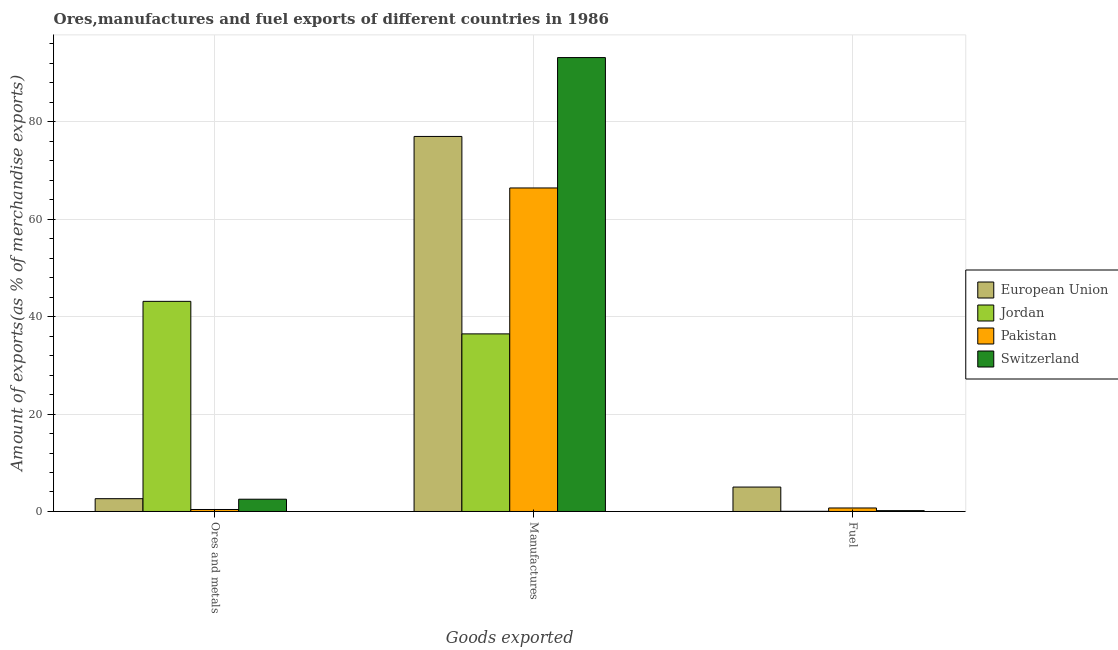How many groups of bars are there?
Give a very brief answer. 3. Are the number of bars on each tick of the X-axis equal?
Offer a very short reply. Yes. What is the label of the 3rd group of bars from the left?
Provide a short and direct response. Fuel. What is the percentage of fuel exports in Jordan?
Make the answer very short. 0.04. Across all countries, what is the maximum percentage of ores and metals exports?
Offer a terse response. 43.12. Across all countries, what is the minimum percentage of manufactures exports?
Ensure brevity in your answer.  36.45. In which country was the percentage of manufactures exports maximum?
Your answer should be compact. Switzerland. What is the total percentage of manufactures exports in the graph?
Provide a short and direct response. 272.94. What is the difference between the percentage of ores and metals exports in Pakistan and that in Jordan?
Your answer should be very brief. -42.71. What is the difference between the percentage of ores and metals exports in European Union and the percentage of manufactures exports in Switzerland?
Provide a succinct answer. -90.52. What is the average percentage of fuel exports per country?
Offer a terse response. 1.49. What is the difference between the percentage of manufactures exports and percentage of fuel exports in European Union?
Give a very brief answer. 71.95. What is the ratio of the percentage of fuel exports in Switzerland to that in Jordan?
Your answer should be very brief. 4.52. Is the difference between the percentage of fuel exports in Jordan and Switzerland greater than the difference between the percentage of manufactures exports in Jordan and Switzerland?
Keep it short and to the point. Yes. What is the difference between the highest and the second highest percentage of manufactures exports?
Your answer should be very brief. 16.19. What is the difference between the highest and the lowest percentage of ores and metals exports?
Offer a terse response. 42.71. In how many countries, is the percentage of ores and metals exports greater than the average percentage of ores and metals exports taken over all countries?
Keep it short and to the point. 1. Is the sum of the percentage of manufactures exports in European Union and Switzerland greater than the maximum percentage of fuel exports across all countries?
Ensure brevity in your answer.  Yes. What does the 4th bar from the left in Ores and metals represents?
Make the answer very short. Switzerland. What does the 3rd bar from the right in Manufactures represents?
Your answer should be very brief. Jordan. How many countries are there in the graph?
Make the answer very short. 4. Does the graph contain grids?
Give a very brief answer. Yes. Where does the legend appear in the graph?
Offer a terse response. Center right. How many legend labels are there?
Your answer should be very brief. 4. How are the legend labels stacked?
Give a very brief answer. Vertical. What is the title of the graph?
Your answer should be compact. Ores,manufactures and fuel exports of different countries in 1986. Does "Luxembourg" appear as one of the legend labels in the graph?
Your answer should be compact. No. What is the label or title of the X-axis?
Offer a very short reply. Goods exported. What is the label or title of the Y-axis?
Your response must be concise. Amount of exports(as % of merchandise exports). What is the Amount of exports(as % of merchandise exports) in European Union in Ores and metals?
Make the answer very short. 2.63. What is the Amount of exports(as % of merchandise exports) of Jordan in Ores and metals?
Ensure brevity in your answer.  43.12. What is the Amount of exports(as % of merchandise exports) of Pakistan in Ores and metals?
Your answer should be very brief. 0.41. What is the Amount of exports(as % of merchandise exports) in Switzerland in Ores and metals?
Offer a terse response. 2.52. What is the Amount of exports(as % of merchandise exports) of European Union in Manufactures?
Keep it short and to the point. 76.96. What is the Amount of exports(as % of merchandise exports) of Jordan in Manufactures?
Offer a very short reply. 36.45. What is the Amount of exports(as % of merchandise exports) in Pakistan in Manufactures?
Your answer should be compact. 66.39. What is the Amount of exports(as % of merchandise exports) of Switzerland in Manufactures?
Provide a short and direct response. 93.15. What is the Amount of exports(as % of merchandise exports) in European Union in Fuel?
Keep it short and to the point. 5.01. What is the Amount of exports(as % of merchandise exports) of Jordan in Fuel?
Make the answer very short. 0.04. What is the Amount of exports(as % of merchandise exports) of Pakistan in Fuel?
Your answer should be very brief. 0.72. What is the Amount of exports(as % of merchandise exports) in Switzerland in Fuel?
Offer a terse response. 0.17. Across all Goods exported, what is the maximum Amount of exports(as % of merchandise exports) in European Union?
Your response must be concise. 76.96. Across all Goods exported, what is the maximum Amount of exports(as % of merchandise exports) of Jordan?
Offer a terse response. 43.12. Across all Goods exported, what is the maximum Amount of exports(as % of merchandise exports) of Pakistan?
Offer a very short reply. 66.39. Across all Goods exported, what is the maximum Amount of exports(as % of merchandise exports) in Switzerland?
Provide a succinct answer. 93.15. Across all Goods exported, what is the minimum Amount of exports(as % of merchandise exports) of European Union?
Provide a short and direct response. 2.63. Across all Goods exported, what is the minimum Amount of exports(as % of merchandise exports) in Jordan?
Your answer should be compact. 0.04. Across all Goods exported, what is the minimum Amount of exports(as % of merchandise exports) in Pakistan?
Your answer should be very brief. 0.41. Across all Goods exported, what is the minimum Amount of exports(as % of merchandise exports) in Switzerland?
Your response must be concise. 0.17. What is the total Amount of exports(as % of merchandise exports) of European Union in the graph?
Give a very brief answer. 84.6. What is the total Amount of exports(as % of merchandise exports) in Jordan in the graph?
Provide a succinct answer. 79.6. What is the total Amount of exports(as % of merchandise exports) of Pakistan in the graph?
Your answer should be compact. 67.52. What is the total Amount of exports(as % of merchandise exports) in Switzerland in the graph?
Offer a terse response. 95.84. What is the difference between the Amount of exports(as % of merchandise exports) of European Union in Ores and metals and that in Manufactures?
Ensure brevity in your answer.  -74.33. What is the difference between the Amount of exports(as % of merchandise exports) of Jordan in Ores and metals and that in Manufactures?
Give a very brief answer. 6.67. What is the difference between the Amount of exports(as % of merchandise exports) of Pakistan in Ores and metals and that in Manufactures?
Offer a very short reply. -65.98. What is the difference between the Amount of exports(as % of merchandise exports) in Switzerland in Ores and metals and that in Manufactures?
Provide a short and direct response. -90.63. What is the difference between the Amount of exports(as % of merchandise exports) of European Union in Ores and metals and that in Fuel?
Provide a short and direct response. -2.39. What is the difference between the Amount of exports(as % of merchandise exports) of Jordan in Ores and metals and that in Fuel?
Provide a succinct answer. 43.08. What is the difference between the Amount of exports(as % of merchandise exports) of Pakistan in Ores and metals and that in Fuel?
Provide a succinct answer. -0.31. What is the difference between the Amount of exports(as % of merchandise exports) in Switzerland in Ores and metals and that in Fuel?
Keep it short and to the point. 2.35. What is the difference between the Amount of exports(as % of merchandise exports) in European Union in Manufactures and that in Fuel?
Your answer should be very brief. 71.95. What is the difference between the Amount of exports(as % of merchandise exports) of Jordan in Manufactures and that in Fuel?
Give a very brief answer. 36.41. What is the difference between the Amount of exports(as % of merchandise exports) in Pakistan in Manufactures and that in Fuel?
Your answer should be very brief. 65.67. What is the difference between the Amount of exports(as % of merchandise exports) of Switzerland in Manufactures and that in Fuel?
Your answer should be very brief. 92.98. What is the difference between the Amount of exports(as % of merchandise exports) in European Union in Ores and metals and the Amount of exports(as % of merchandise exports) in Jordan in Manufactures?
Offer a terse response. -33.82. What is the difference between the Amount of exports(as % of merchandise exports) of European Union in Ores and metals and the Amount of exports(as % of merchandise exports) of Pakistan in Manufactures?
Offer a terse response. -63.76. What is the difference between the Amount of exports(as % of merchandise exports) of European Union in Ores and metals and the Amount of exports(as % of merchandise exports) of Switzerland in Manufactures?
Offer a terse response. -90.52. What is the difference between the Amount of exports(as % of merchandise exports) in Jordan in Ores and metals and the Amount of exports(as % of merchandise exports) in Pakistan in Manufactures?
Provide a short and direct response. -23.27. What is the difference between the Amount of exports(as % of merchandise exports) in Jordan in Ores and metals and the Amount of exports(as % of merchandise exports) in Switzerland in Manufactures?
Make the answer very short. -50.03. What is the difference between the Amount of exports(as % of merchandise exports) in Pakistan in Ores and metals and the Amount of exports(as % of merchandise exports) in Switzerland in Manufactures?
Provide a short and direct response. -92.74. What is the difference between the Amount of exports(as % of merchandise exports) of European Union in Ores and metals and the Amount of exports(as % of merchandise exports) of Jordan in Fuel?
Provide a succinct answer. 2.59. What is the difference between the Amount of exports(as % of merchandise exports) of European Union in Ores and metals and the Amount of exports(as % of merchandise exports) of Pakistan in Fuel?
Keep it short and to the point. 1.91. What is the difference between the Amount of exports(as % of merchandise exports) in European Union in Ores and metals and the Amount of exports(as % of merchandise exports) in Switzerland in Fuel?
Offer a terse response. 2.46. What is the difference between the Amount of exports(as % of merchandise exports) of Jordan in Ores and metals and the Amount of exports(as % of merchandise exports) of Pakistan in Fuel?
Your response must be concise. 42.4. What is the difference between the Amount of exports(as % of merchandise exports) in Jordan in Ores and metals and the Amount of exports(as % of merchandise exports) in Switzerland in Fuel?
Ensure brevity in your answer.  42.95. What is the difference between the Amount of exports(as % of merchandise exports) of Pakistan in Ores and metals and the Amount of exports(as % of merchandise exports) of Switzerland in Fuel?
Your answer should be very brief. 0.24. What is the difference between the Amount of exports(as % of merchandise exports) in European Union in Manufactures and the Amount of exports(as % of merchandise exports) in Jordan in Fuel?
Provide a succinct answer. 76.92. What is the difference between the Amount of exports(as % of merchandise exports) in European Union in Manufactures and the Amount of exports(as % of merchandise exports) in Pakistan in Fuel?
Offer a terse response. 76.24. What is the difference between the Amount of exports(as % of merchandise exports) of European Union in Manufactures and the Amount of exports(as % of merchandise exports) of Switzerland in Fuel?
Your response must be concise. 76.79. What is the difference between the Amount of exports(as % of merchandise exports) of Jordan in Manufactures and the Amount of exports(as % of merchandise exports) of Pakistan in Fuel?
Offer a terse response. 35.73. What is the difference between the Amount of exports(as % of merchandise exports) in Jordan in Manufactures and the Amount of exports(as % of merchandise exports) in Switzerland in Fuel?
Your answer should be very brief. 36.28. What is the difference between the Amount of exports(as % of merchandise exports) of Pakistan in Manufactures and the Amount of exports(as % of merchandise exports) of Switzerland in Fuel?
Offer a very short reply. 66.22. What is the average Amount of exports(as % of merchandise exports) in European Union per Goods exported?
Provide a short and direct response. 28.2. What is the average Amount of exports(as % of merchandise exports) of Jordan per Goods exported?
Ensure brevity in your answer.  26.53. What is the average Amount of exports(as % of merchandise exports) in Pakistan per Goods exported?
Offer a very short reply. 22.51. What is the average Amount of exports(as % of merchandise exports) in Switzerland per Goods exported?
Your response must be concise. 31.95. What is the difference between the Amount of exports(as % of merchandise exports) in European Union and Amount of exports(as % of merchandise exports) in Jordan in Ores and metals?
Provide a short and direct response. -40.49. What is the difference between the Amount of exports(as % of merchandise exports) of European Union and Amount of exports(as % of merchandise exports) of Pakistan in Ores and metals?
Your answer should be very brief. 2.22. What is the difference between the Amount of exports(as % of merchandise exports) of European Union and Amount of exports(as % of merchandise exports) of Switzerland in Ores and metals?
Give a very brief answer. 0.11. What is the difference between the Amount of exports(as % of merchandise exports) in Jordan and Amount of exports(as % of merchandise exports) in Pakistan in Ores and metals?
Provide a succinct answer. 42.71. What is the difference between the Amount of exports(as % of merchandise exports) of Jordan and Amount of exports(as % of merchandise exports) of Switzerland in Ores and metals?
Offer a very short reply. 40.6. What is the difference between the Amount of exports(as % of merchandise exports) of Pakistan and Amount of exports(as % of merchandise exports) of Switzerland in Ores and metals?
Your answer should be very brief. -2.11. What is the difference between the Amount of exports(as % of merchandise exports) of European Union and Amount of exports(as % of merchandise exports) of Jordan in Manufactures?
Keep it short and to the point. 40.51. What is the difference between the Amount of exports(as % of merchandise exports) in European Union and Amount of exports(as % of merchandise exports) in Pakistan in Manufactures?
Provide a short and direct response. 10.57. What is the difference between the Amount of exports(as % of merchandise exports) in European Union and Amount of exports(as % of merchandise exports) in Switzerland in Manufactures?
Your answer should be compact. -16.19. What is the difference between the Amount of exports(as % of merchandise exports) in Jordan and Amount of exports(as % of merchandise exports) in Pakistan in Manufactures?
Offer a very short reply. -29.94. What is the difference between the Amount of exports(as % of merchandise exports) in Jordan and Amount of exports(as % of merchandise exports) in Switzerland in Manufactures?
Offer a terse response. -56.7. What is the difference between the Amount of exports(as % of merchandise exports) of Pakistan and Amount of exports(as % of merchandise exports) of Switzerland in Manufactures?
Offer a terse response. -26.76. What is the difference between the Amount of exports(as % of merchandise exports) of European Union and Amount of exports(as % of merchandise exports) of Jordan in Fuel?
Offer a terse response. 4.97. What is the difference between the Amount of exports(as % of merchandise exports) in European Union and Amount of exports(as % of merchandise exports) in Pakistan in Fuel?
Your answer should be compact. 4.29. What is the difference between the Amount of exports(as % of merchandise exports) of European Union and Amount of exports(as % of merchandise exports) of Switzerland in Fuel?
Keep it short and to the point. 4.84. What is the difference between the Amount of exports(as % of merchandise exports) in Jordan and Amount of exports(as % of merchandise exports) in Pakistan in Fuel?
Provide a short and direct response. -0.68. What is the difference between the Amount of exports(as % of merchandise exports) in Jordan and Amount of exports(as % of merchandise exports) in Switzerland in Fuel?
Offer a very short reply. -0.13. What is the difference between the Amount of exports(as % of merchandise exports) in Pakistan and Amount of exports(as % of merchandise exports) in Switzerland in Fuel?
Give a very brief answer. 0.55. What is the ratio of the Amount of exports(as % of merchandise exports) of European Union in Ores and metals to that in Manufactures?
Provide a succinct answer. 0.03. What is the ratio of the Amount of exports(as % of merchandise exports) in Jordan in Ores and metals to that in Manufactures?
Your answer should be very brief. 1.18. What is the ratio of the Amount of exports(as % of merchandise exports) in Pakistan in Ores and metals to that in Manufactures?
Your answer should be very brief. 0.01. What is the ratio of the Amount of exports(as % of merchandise exports) of Switzerland in Ores and metals to that in Manufactures?
Provide a succinct answer. 0.03. What is the ratio of the Amount of exports(as % of merchandise exports) in European Union in Ores and metals to that in Fuel?
Provide a succinct answer. 0.52. What is the ratio of the Amount of exports(as % of merchandise exports) of Jordan in Ores and metals to that in Fuel?
Keep it short and to the point. 1140.5. What is the ratio of the Amount of exports(as % of merchandise exports) of Pakistan in Ores and metals to that in Fuel?
Keep it short and to the point. 0.57. What is the ratio of the Amount of exports(as % of merchandise exports) in Switzerland in Ores and metals to that in Fuel?
Keep it short and to the point. 14.75. What is the ratio of the Amount of exports(as % of merchandise exports) of European Union in Manufactures to that in Fuel?
Your answer should be very brief. 15.35. What is the ratio of the Amount of exports(as % of merchandise exports) in Jordan in Manufactures to that in Fuel?
Make the answer very short. 964. What is the ratio of the Amount of exports(as % of merchandise exports) of Pakistan in Manufactures to that in Fuel?
Make the answer very short. 92.3. What is the ratio of the Amount of exports(as % of merchandise exports) of Switzerland in Manufactures to that in Fuel?
Your answer should be very brief. 545.52. What is the difference between the highest and the second highest Amount of exports(as % of merchandise exports) of European Union?
Offer a terse response. 71.95. What is the difference between the highest and the second highest Amount of exports(as % of merchandise exports) in Jordan?
Your answer should be compact. 6.67. What is the difference between the highest and the second highest Amount of exports(as % of merchandise exports) in Pakistan?
Your answer should be compact. 65.67. What is the difference between the highest and the second highest Amount of exports(as % of merchandise exports) of Switzerland?
Offer a terse response. 90.63. What is the difference between the highest and the lowest Amount of exports(as % of merchandise exports) in European Union?
Provide a short and direct response. 74.33. What is the difference between the highest and the lowest Amount of exports(as % of merchandise exports) of Jordan?
Offer a terse response. 43.08. What is the difference between the highest and the lowest Amount of exports(as % of merchandise exports) in Pakistan?
Keep it short and to the point. 65.98. What is the difference between the highest and the lowest Amount of exports(as % of merchandise exports) of Switzerland?
Your answer should be very brief. 92.98. 